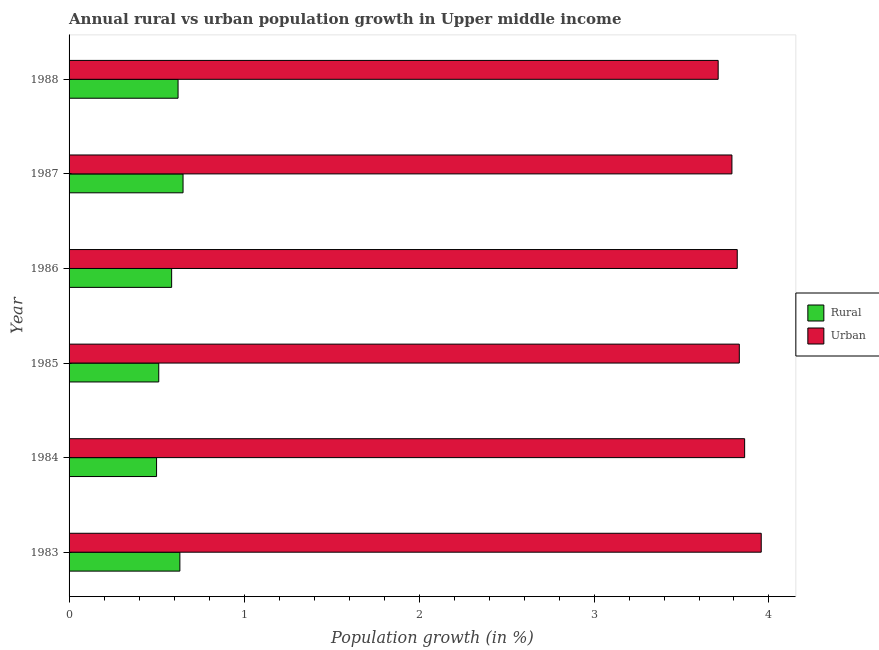How many different coloured bars are there?
Make the answer very short. 2. Are the number of bars per tick equal to the number of legend labels?
Give a very brief answer. Yes. How many bars are there on the 1st tick from the top?
Provide a succinct answer. 2. How many bars are there on the 4th tick from the bottom?
Provide a short and direct response. 2. What is the label of the 6th group of bars from the top?
Your answer should be very brief. 1983. In how many cases, is the number of bars for a given year not equal to the number of legend labels?
Your answer should be very brief. 0. What is the rural population growth in 1987?
Offer a very short reply. 0.65. Across all years, what is the maximum rural population growth?
Your answer should be compact. 0.65. Across all years, what is the minimum rural population growth?
Keep it short and to the point. 0.5. What is the total urban population growth in the graph?
Your answer should be compact. 22.96. What is the difference between the urban population growth in 1985 and that in 1987?
Your answer should be compact. 0.04. What is the difference between the urban population growth in 1987 and the rural population growth in 1983?
Keep it short and to the point. 3.15. What is the average urban population growth per year?
Provide a short and direct response. 3.83. In the year 1987, what is the difference between the rural population growth and urban population growth?
Offer a very short reply. -3.14. In how many years, is the urban population growth greater than 3.2 %?
Provide a short and direct response. 6. What is the ratio of the rural population growth in 1983 to that in 1986?
Your response must be concise. 1.08. Is the difference between the rural population growth in 1984 and 1986 greater than the difference between the urban population growth in 1984 and 1986?
Provide a short and direct response. No. What is the difference between the highest and the second highest rural population growth?
Ensure brevity in your answer.  0.02. What is the difference between the highest and the lowest rural population growth?
Ensure brevity in your answer.  0.15. What does the 1st bar from the top in 1984 represents?
Ensure brevity in your answer.  Urban . What does the 2nd bar from the bottom in 1987 represents?
Give a very brief answer. Urban . Are all the bars in the graph horizontal?
Your response must be concise. Yes. How many years are there in the graph?
Give a very brief answer. 6. Does the graph contain any zero values?
Give a very brief answer. No. Does the graph contain grids?
Make the answer very short. No. Where does the legend appear in the graph?
Make the answer very short. Center right. How many legend labels are there?
Give a very brief answer. 2. How are the legend labels stacked?
Keep it short and to the point. Vertical. What is the title of the graph?
Provide a succinct answer. Annual rural vs urban population growth in Upper middle income. What is the label or title of the X-axis?
Offer a very short reply. Population growth (in %). What is the Population growth (in %) in Rural in 1983?
Provide a short and direct response. 0.63. What is the Population growth (in %) in Urban  in 1983?
Ensure brevity in your answer.  3.96. What is the Population growth (in %) of Rural in 1984?
Your answer should be compact. 0.5. What is the Population growth (in %) in Urban  in 1984?
Keep it short and to the point. 3.86. What is the Population growth (in %) in Rural in 1985?
Offer a very short reply. 0.51. What is the Population growth (in %) in Urban  in 1985?
Make the answer very short. 3.83. What is the Population growth (in %) in Rural in 1986?
Your response must be concise. 0.59. What is the Population growth (in %) in Urban  in 1986?
Your answer should be compact. 3.82. What is the Population growth (in %) in Rural in 1987?
Your answer should be very brief. 0.65. What is the Population growth (in %) of Urban  in 1987?
Your response must be concise. 3.79. What is the Population growth (in %) in Rural in 1988?
Make the answer very short. 0.62. What is the Population growth (in %) of Urban  in 1988?
Provide a short and direct response. 3.71. Across all years, what is the maximum Population growth (in %) of Rural?
Your answer should be very brief. 0.65. Across all years, what is the maximum Population growth (in %) in Urban ?
Make the answer very short. 3.96. Across all years, what is the minimum Population growth (in %) of Rural?
Offer a terse response. 0.5. Across all years, what is the minimum Population growth (in %) of Urban ?
Your answer should be compact. 3.71. What is the total Population growth (in %) of Rural in the graph?
Provide a short and direct response. 3.51. What is the total Population growth (in %) of Urban  in the graph?
Provide a succinct answer. 22.96. What is the difference between the Population growth (in %) of Rural in 1983 and that in 1984?
Your response must be concise. 0.13. What is the difference between the Population growth (in %) of Urban  in 1983 and that in 1984?
Provide a succinct answer. 0.09. What is the difference between the Population growth (in %) in Rural in 1983 and that in 1985?
Your response must be concise. 0.12. What is the difference between the Population growth (in %) in Urban  in 1983 and that in 1985?
Ensure brevity in your answer.  0.13. What is the difference between the Population growth (in %) in Rural in 1983 and that in 1986?
Make the answer very short. 0.05. What is the difference between the Population growth (in %) in Urban  in 1983 and that in 1986?
Offer a terse response. 0.14. What is the difference between the Population growth (in %) of Rural in 1983 and that in 1987?
Offer a terse response. -0.02. What is the difference between the Population growth (in %) of Urban  in 1983 and that in 1987?
Make the answer very short. 0.17. What is the difference between the Population growth (in %) in Rural in 1983 and that in 1988?
Provide a short and direct response. 0.01. What is the difference between the Population growth (in %) of Urban  in 1983 and that in 1988?
Give a very brief answer. 0.25. What is the difference between the Population growth (in %) of Rural in 1984 and that in 1985?
Make the answer very short. -0.01. What is the difference between the Population growth (in %) in Urban  in 1984 and that in 1985?
Offer a very short reply. 0.03. What is the difference between the Population growth (in %) of Rural in 1984 and that in 1986?
Offer a very short reply. -0.09. What is the difference between the Population growth (in %) of Urban  in 1984 and that in 1986?
Offer a very short reply. 0.04. What is the difference between the Population growth (in %) in Rural in 1984 and that in 1987?
Make the answer very short. -0.15. What is the difference between the Population growth (in %) in Urban  in 1984 and that in 1987?
Make the answer very short. 0.07. What is the difference between the Population growth (in %) in Rural in 1984 and that in 1988?
Provide a short and direct response. -0.12. What is the difference between the Population growth (in %) in Urban  in 1984 and that in 1988?
Provide a succinct answer. 0.15. What is the difference between the Population growth (in %) in Rural in 1985 and that in 1986?
Provide a succinct answer. -0.07. What is the difference between the Population growth (in %) of Urban  in 1985 and that in 1986?
Your answer should be compact. 0.01. What is the difference between the Population growth (in %) in Rural in 1985 and that in 1987?
Your response must be concise. -0.14. What is the difference between the Population growth (in %) in Urban  in 1985 and that in 1987?
Make the answer very short. 0.04. What is the difference between the Population growth (in %) in Rural in 1985 and that in 1988?
Offer a terse response. -0.11. What is the difference between the Population growth (in %) of Urban  in 1985 and that in 1988?
Give a very brief answer. 0.12. What is the difference between the Population growth (in %) of Rural in 1986 and that in 1987?
Offer a terse response. -0.07. What is the difference between the Population growth (in %) in Urban  in 1986 and that in 1987?
Give a very brief answer. 0.03. What is the difference between the Population growth (in %) of Rural in 1986 and that in 1988?
Your answer should be very brief. -0.04. What is the difference between the Population growth (in %) in Urban  in 1986 and that in 1988?
Offer a very short reply. 0.11. What is the difference between the Population growth (in %) in Rural in 1987 and that in 1988?
Provide a short and direct response. 0.03. What is the difference between the Population growth (in %) of Urban  in 1987 and that in 1988?
Offer a terse response. 0.08. What is the difference between the Population growth (in %) of Rural in 1983 and the Population growth (in %) of Urban  in 1984?
Your answer should be compact. -3.23. What is the difference between the Population growth (in %) in Rural in 1983 and the Population growth (in %) in Urban  in 1985?
Your response must be concise. -3.2. What is the difference between the Population growth (in %) of Rural in 1983 and the Population growth (in %) of Urban  in 1986?
Give a very brief answer. -3.19. What is the difference between the Population growth (in %) of Rural in 1983 and the Population growth (in %) of Urban  in 1987?
Your response must be concise. -3.15. What is the difference between the Population growth (in %) in Rural in 1983 and the Population growth (in %) in Urban  in 1988?
Your answer should be compact. -3.08. What is the difference between the Population growth (in %) of Rural in 1984 and the Population growth (in %) of Urban  in 1985?
Offer a terse response. -3.33. What is the difference between the Population growth (in %) of Rural in 1984 and the Population growth (in %) of Urban  in 1986?
Your answer should be compact. -3.32. What is the difference between the Population growth (in %) of Rural in 1984 and the Population growth (in %) of Urban  in 1987?
Keep it short and to the point. -3.29. What is the difference between the Population growth (in %) in Rural in 1984 and the Population growth (in %) in Urban  in 1988?
Your response must be concise. -3.21. What is the difference between the Population growth (in %) in Rural in 1985 and the Population growth (in %) in Urban  in 1986?
Provide a short and direct response. -3.31. What is the difference between the Population growth (in %) in Rural in 1985 and the Population growth (in %) in Urban  in 1987?
Your answer should be very brief. -3.28. What is the difference between the Population growth (in %) of Rural in 1985 and the Population growth (in %) of Urban  in 1988?
Provide a short and direct response. -3.2. What is the difference between the Population growth (in %) in Rural in 1986 and the Population growth (in %) in Urban  in 1987?
Make the answer very short. -3.2. What is the difference between the Population growth (in %) in Rural in 1986 and the Population growth (in %) in Urban  in 1988?
Your answer should be compact. -3.12. What is the difference between the Population growth (in %) of Rural in 1987 and the Population growth (in %) of Urban  in 1988?
Keep it short and to the point. -3.06. What is the average Population growth (in %) of Rural per year?
Your answer should be very brief. 0.58. What is the average Population growth (in %) of Urban  per year?
Ensure brevity in your answer.  3.83. In the year 1983, what is the difference between the Population growth (in %) of Rural and Population growth (in %) of Urban ?
Provide a short and direct response. -3.32. In the year 1984, what is the difference between the Population growth (in %) of Rural and Population growth (in %) of Urban ?
Ensure brevity in your answer.  -3.36. In the year 1985, what is the difference between the Population growth (in %) in Rural and Population growth (in %) in Urban ?
Your answer should be compact. -3.32. In the year 1986, what is the difference between the Population growth (in %) of Rural and Population growth (in %) of Urban ?
Provide a succinct answer. -3.23. In the year 1987, what is the difference between the Population growth (in %) of Rural and Population growth (in %) of Urban ?
Offer a terse response. -3.14. In the year 1988, what is the difference between the Population growth (in %) of Rural and Population growth (in %) of Urban ?
Provide a short and direct response. -3.09. What is the ratio of the Population growth (in %) in Rural in 1983 to that in 1984?
Your answer should be very brief. 1.27. What is the ratio of the Population growth (in %) of Urban  in 1983 to that in 1984?
Provide a short and direct response. 1.02. What is the ratio of the Population growth (in %) in Rural in 1983 to that in 1985?
Offer a terse response. 1.24. What is the ratio of the Population growth (in %) in Urban  in 1983 to that in 1985?
Provide a succinct answer. 1.03. What is the ratio of the Population growth (in %) in Rural in 1983 to that in 1986?
Offer a terse response. 1.08. What is the ratio of the Population growth (in %) of Urban  in 1983 to that in 1986?
Your response must be concise. 1.04. What is the ratio of the Population growth (in %) in Rural in 1983 to that in 1987?
Ensure brevity in your answer.  0.97. What is the ratio of the Population growth (in %) of Urban  in 1983 to that in 1987?
Ensure brevity in your answer.  1.04. What is the ratio of the Population growth (in %) of Rural in 1983 to that in 1988?
Your response must be concise. 1.02. What is the ratio of the Population growth (in %) of Urban  in 1983 to that in 1988?
Keep it short and to the point. 1.07. What is the ratio of the Population growth (in %) of Rural in 1984 to that in 1985?
Provide a succinct answer. 0.98. What is the ratio of the Population growth (in %) in Rural in 1984 to that in 1986?
Offer a very short reply. 0.85. What is the ratio of the Population growth (in %) in Urban  in 1984 to that in 1986?
Make the answer very short. 1.01. What is the ratio of the Population growth (in %) in Rural in 1984 to that in 1987?
Provide a short and direct response. 0.77. What is the ratio of the Population growth (in %) of Urban  in 1984 to that in 1987?
Provide a succinct answer. 1.02. What is the ratio of the Population growth (in %) in Rural in 1984 to that in 1988?
Your response must be concise. 0.8. What is the ratio of the Population growth (in %) in Urban  in 1984 to that in 1988?
Offer a very short reply. 1.04. What is the ratio of the Population growth (in %) of Rural in 1985 to that in 1986?
Provide a short and direct response. 0.87. What is the ratio of the Population growth (in %) in Urban  in 1985 to that in 1986?
Offer a terse response. 1. What is the ratio of the Population growth (in %) of Rural in 1985 to that in 1987?
Keep it short and to the point. 0.79. What is the ratio of the Population growth (in %) of Urban  in 1985 to that in 1987?
Your answer should be very brief. 1.01. What is the ratio of the Population growth (in %) of Rural in 1985 to that in 1988?
Provide a short and direct response. 0.82. What is the ratio of the Population growth (in %) of Urban  in 1985 to that in 1988?
Your answer should be very brief. 1.03. What is the ratio of the Population growth (in %) in Rural in 1986 to that in 1987?
Offer a very short reply. 0.9. What is the ratio of the Population growth (in %) in Rural in 1986 to that in 1988?
Keep it short and to the point. 0.94. What is the ratio of the Population growth (in %) of Urban  in 1986 to that in 1988?
Your response must be concise. 1.03. What is the ratio of the Population growth (in %) of Rural in 1987 to that in 1988?
Give a very brief answer. 1.05. What is the ratio of the Population growth (in %) in Urban  in 1987 to that in 1988?
Your answer should be very brief. 1.02. What is the difference between the highest and the second highest Population growth (in %) of Rural?
Your response must be concise. 0.02. What is the difference between the highest and the second highest Population growth (in %) of Urban ?
Ensure brevity in your answer.  0.09. What is the difference between the highest and the lowest Population growth (in %) of Rural?
Your answer should be very brief. 0.15. What is the difference between the highest and the lowest Population growth (in %) of Urban ?
Your response must be concise. 0.25. 